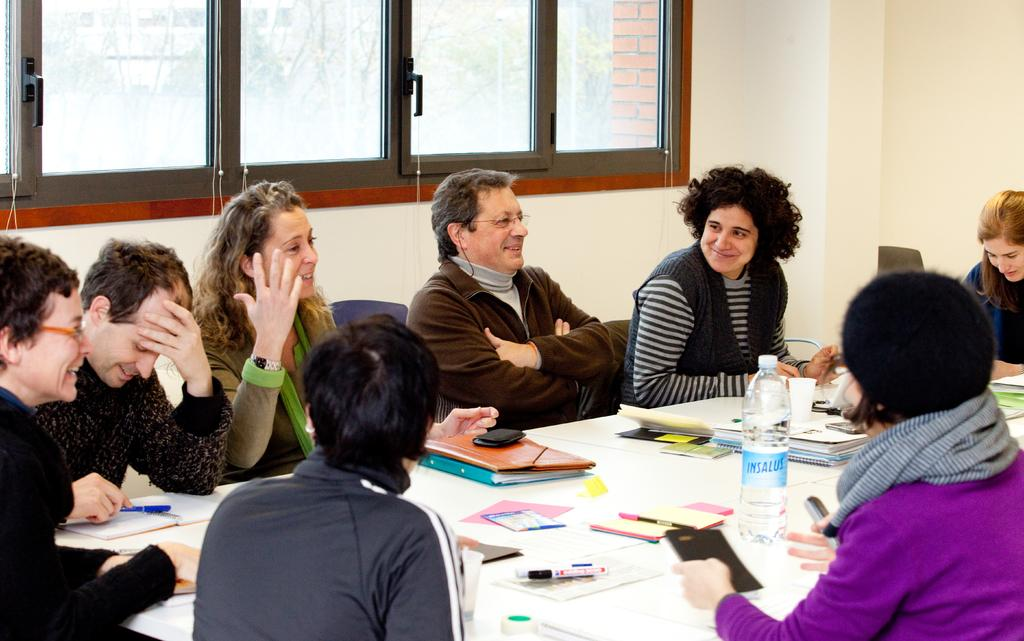How many people are in the image? There is a group of people in the image. What are the people doing in the image? The people are sitting. What is in front of the people? There is a table in front of the people. What items can be seen on the table? There is a water bottle, books, markers, and notepads on the table. What type of document is on the table? There is an Excel sheet on the table. What is visible in the background of the image? There is a window in the background of the image. How many bears are visible in the image? There are no bears present in the image. Is there a sink visible in the image? There is no sink present in the image. 